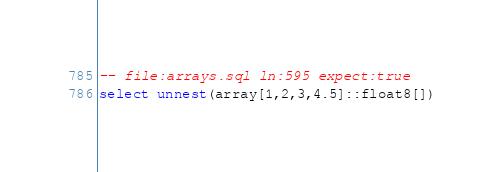Convert code to text. <code><loc_0><loc_0><loc_500><loc_500><_SQL_>-- file:arrays.sql ln:595 expect:true
select unnest(array[1,2,3,4.5]::float8[])
</code> 